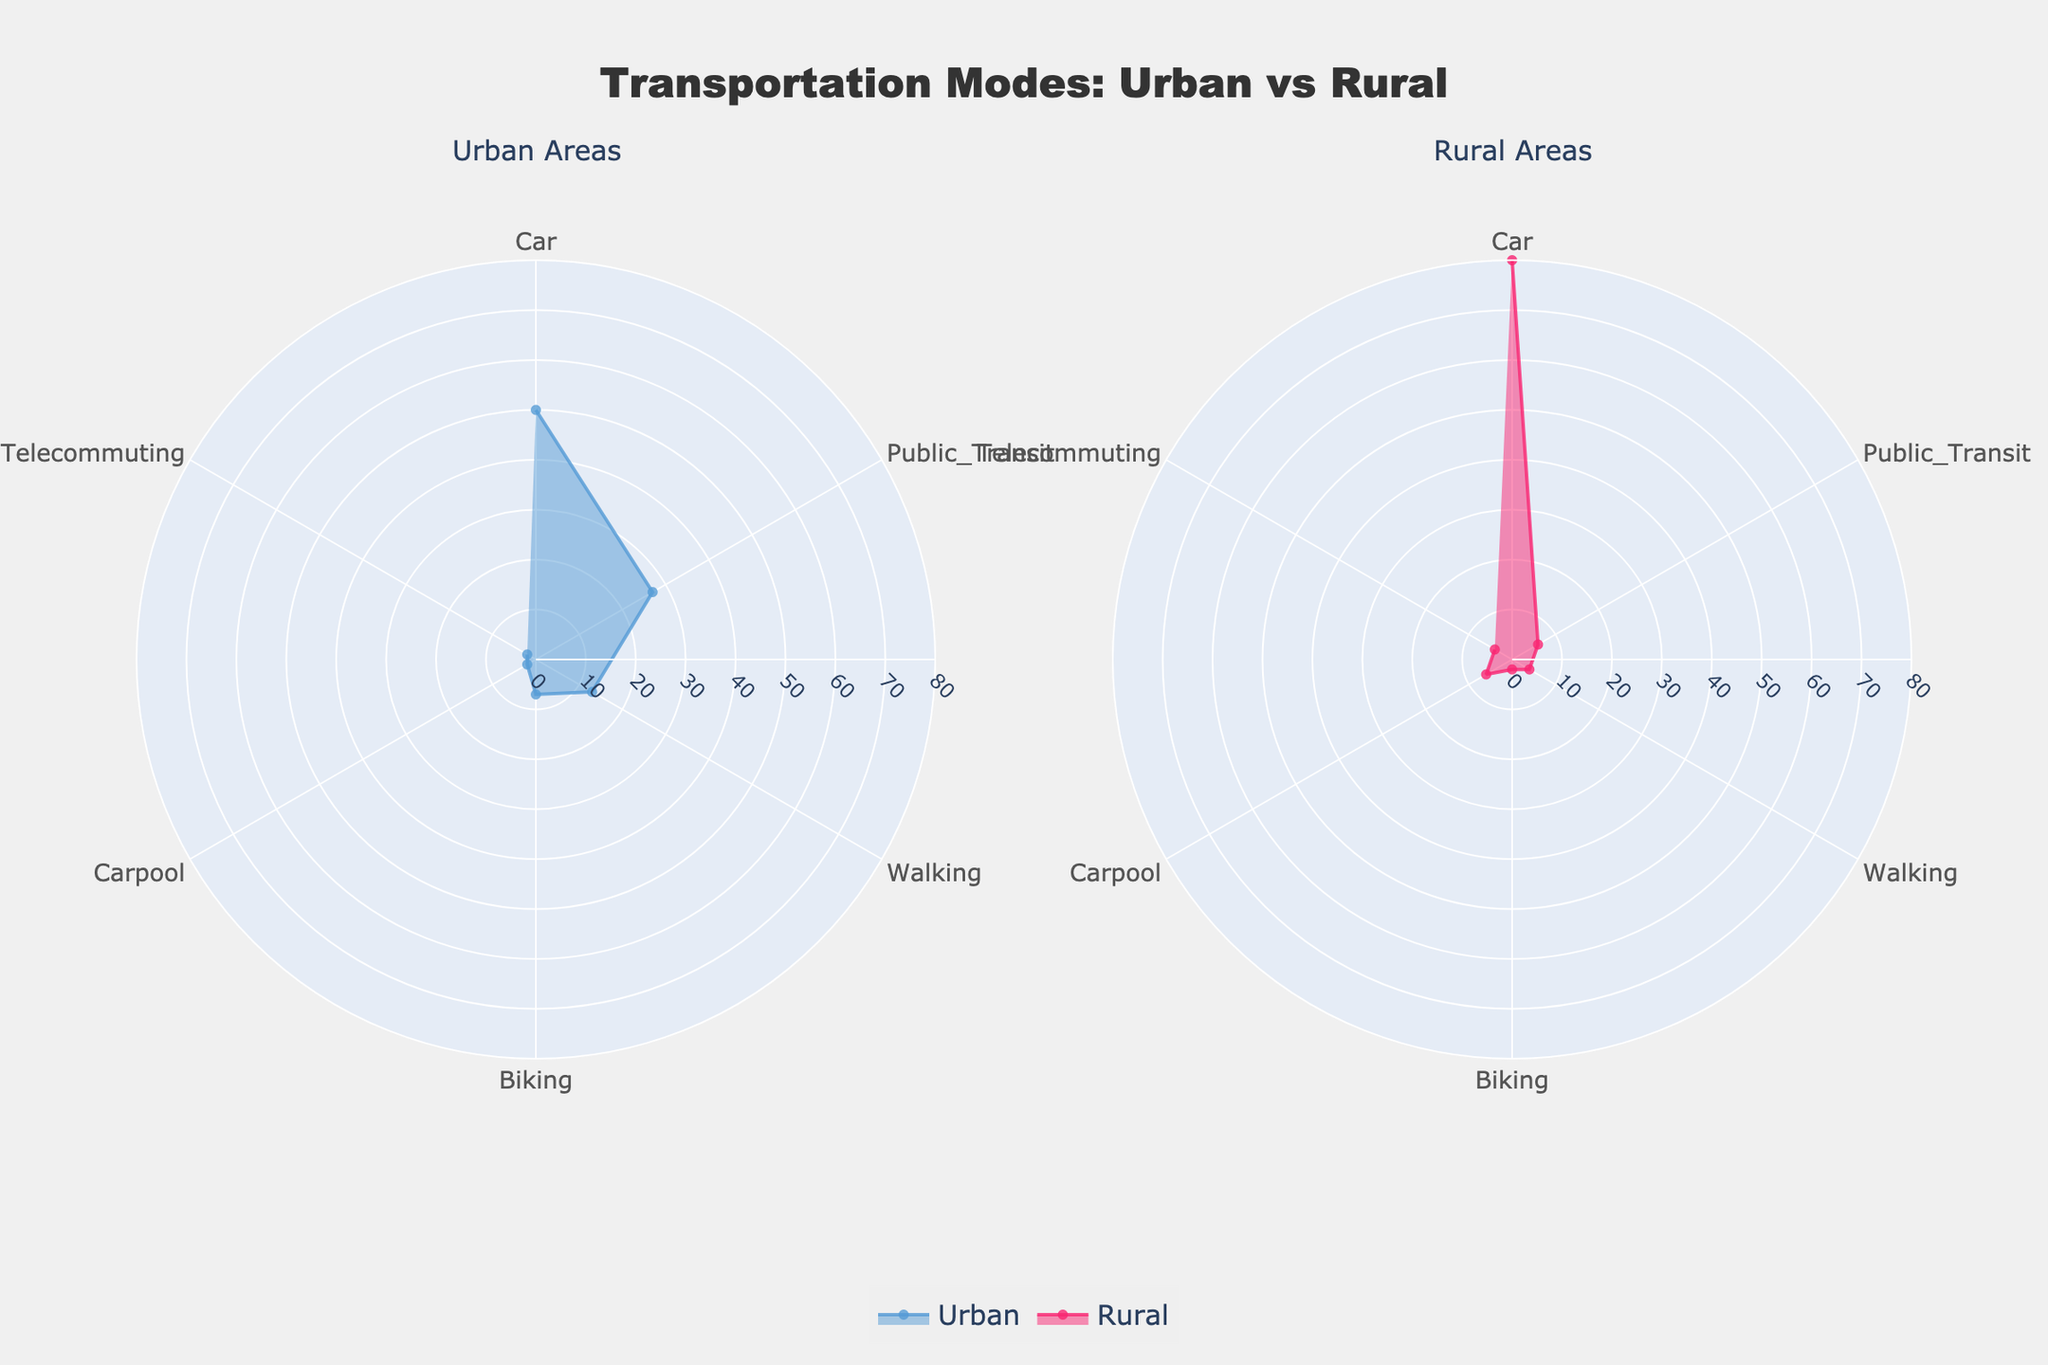What is the title of the chart? The title of the chart is typically located at the top and summarizes what the figure represents. By looking at the chart, we can see that it’s called "Transportation Modes: Urban vs Rural".
Answer: Transportation Modes: Urban vs Rural Which area has a higher percentage of people using cars for their daily commute, Urban or Rural? To determine which area has a higher percentage, compare the values for car use in both the Urban and Rural sections of the chart. The Rural area has a higher percentage (80%) compared to Urban (50%).
Answer: Rural What percentage of people in Urban areas use public transit? Look at the section labeled "Public_Transit" in the Urban area on the chart and read the percentage value.
Answer: 27% By how much does the percentage of people biking differ between Urban and Rural areas? To find the difference, subtract the percentage of people biking in Rural areas (2%) from that in Urban areas (7%). 7% - 2% = 5%.
Answer: 5% Which mode of transportation has the smallest percentage share in Rural areas? Examine the percentages for all transportation modes in the Rural area and identify the smallest value. Carpool, Public_Transit, and Telecommuting all share the smallest percentage of 6%, but Walking is 4%, and Biking is 2%. Therefore, Biking has the smallest share.
Answer: Biking What is the combined percentage of Urban commuters who either bike or walk? Add the percentages for biking (7%) and walking (13%) in the Urban area. 7% + 13% = 20%.
Answer: 20% Which transportation mode has the most significant difference in usage percentage between Urban and Rural areas? Calculate the differences for each mode: Car (80% - 50% = 30%), Public_Transit (27% - 6% = 21%), Walking (13% - 4% = 9%), Biking (7% - 2% = 5%), Carpool (6% - 2% = 4%), Telecommuting (4% - 2% = 2%). The mode with the largest difference is Car (30%).
Answer: Car In Urban areas, what is the difference in percentage points between those who use public transit and those who walk? Subtract the percentage of Urban commuters who walk (13%) from those who use public transit (27%). 27% - 13% = 14%.
Answer: 14% Identify the mode of transportation with the most balanced usage percentage between Urban and Rural areas. Calculate the absolute value of differences for each mode: Car (30%), Public_Transit (21%), Walking (9%), Biking (5%), Carpool (4%), Telecommuting (2%). The most balanced mode is Telecommuting with the smallest difference.
Answer: Telecommuting How many modes of transportation are represented in the chart for each area? Count the unique categories listed in the legend or labels for Urban and Rural areas. Both have the same number of modes.
Answer: 6 